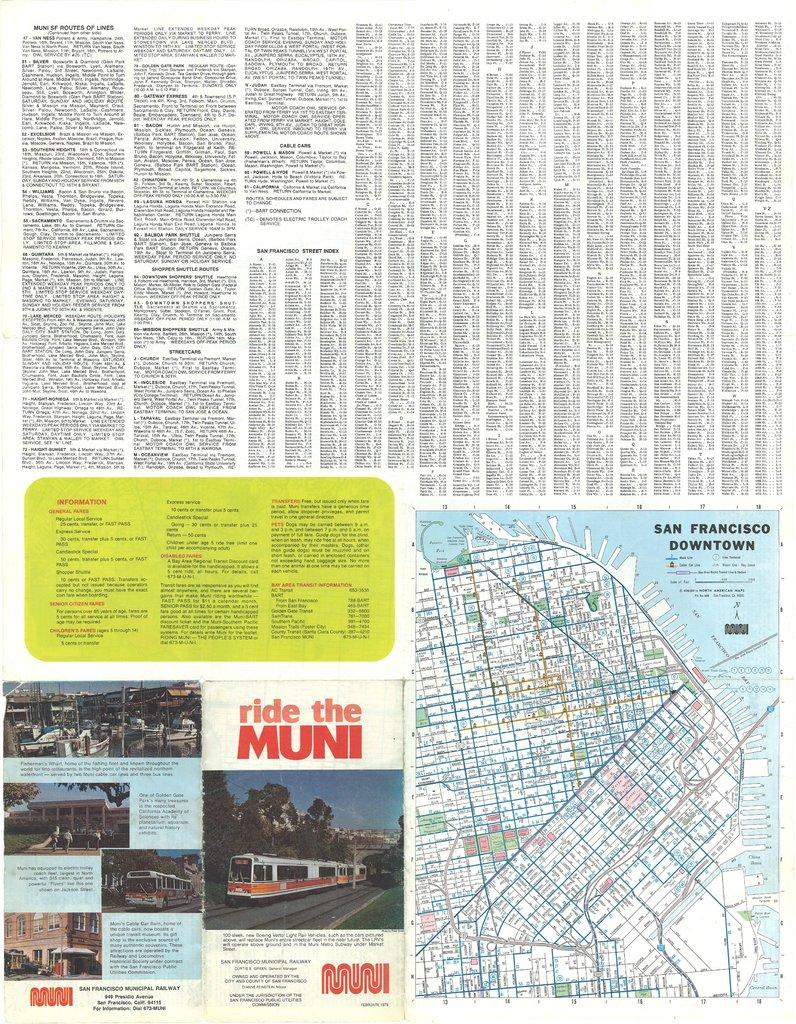What type of image is being described? The image resembles a newspaper column. What can be found within the image? There is text and a map in the image. Are there any vehicles depicted in the image? Yes, there is a bus in the image. Are there any people present in the image? Yes, there are people in the image. What else can be found in the image besides text, a map, a bus, and people? Various objects are present in the image. What type of rice is being served to the donkey in the image? There is no donkey or rice present in the image. 